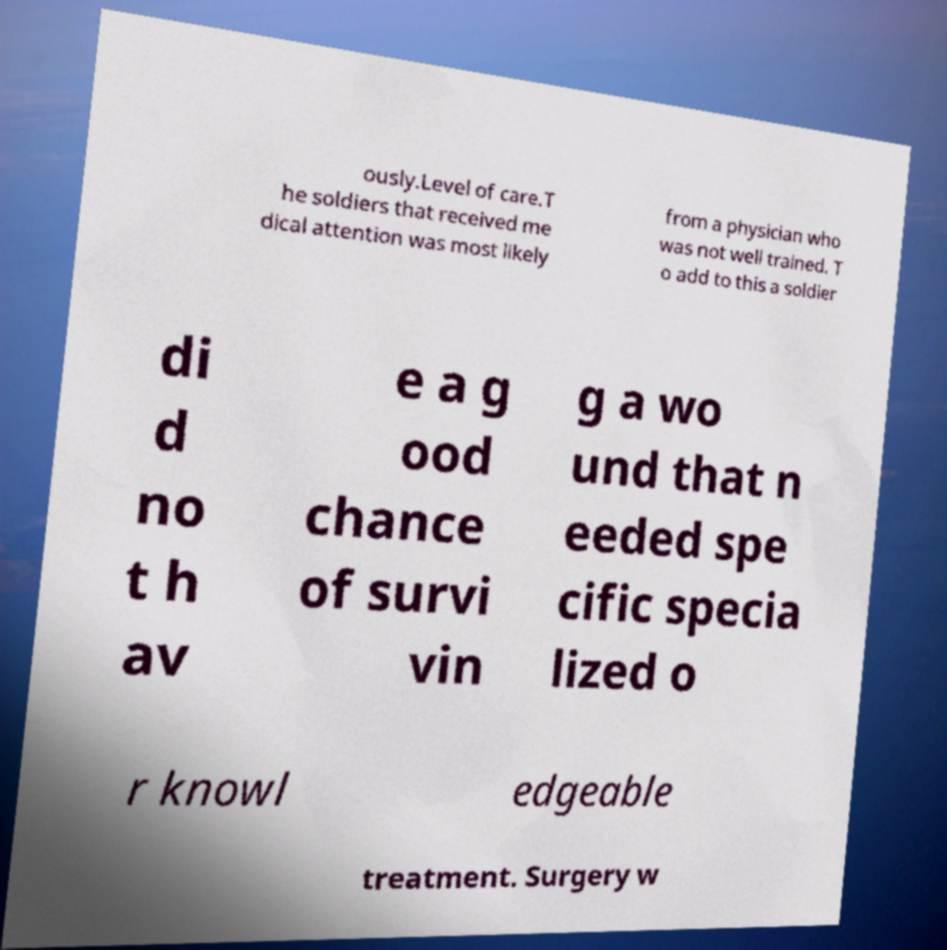Please identify and transcribe the text found in this image. ously.Level of care.T he soldiers that received me dical attention was most likely from a physician who was not well trained. T o add to this a soldier di d no t h av e a g ood chance of survi vin g a wo und that n eeded spe cific specia lized o r knowl edgeable treatment. Surgery w 